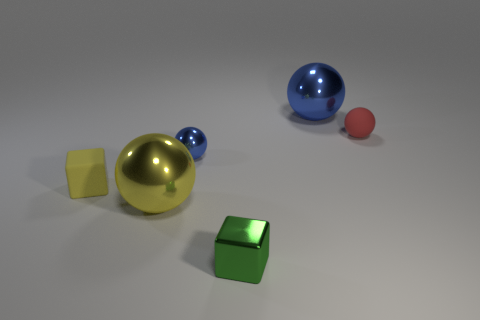What number of objects are right of the tiny yellow cube and in front of the large blue shiny object? Between the small, yellow cube to the right and the large, blue reflective sphere in the back, there appears to be one object—a green cube, which is situated in front of the large blue object but to the right of the tiny yellow cube. 